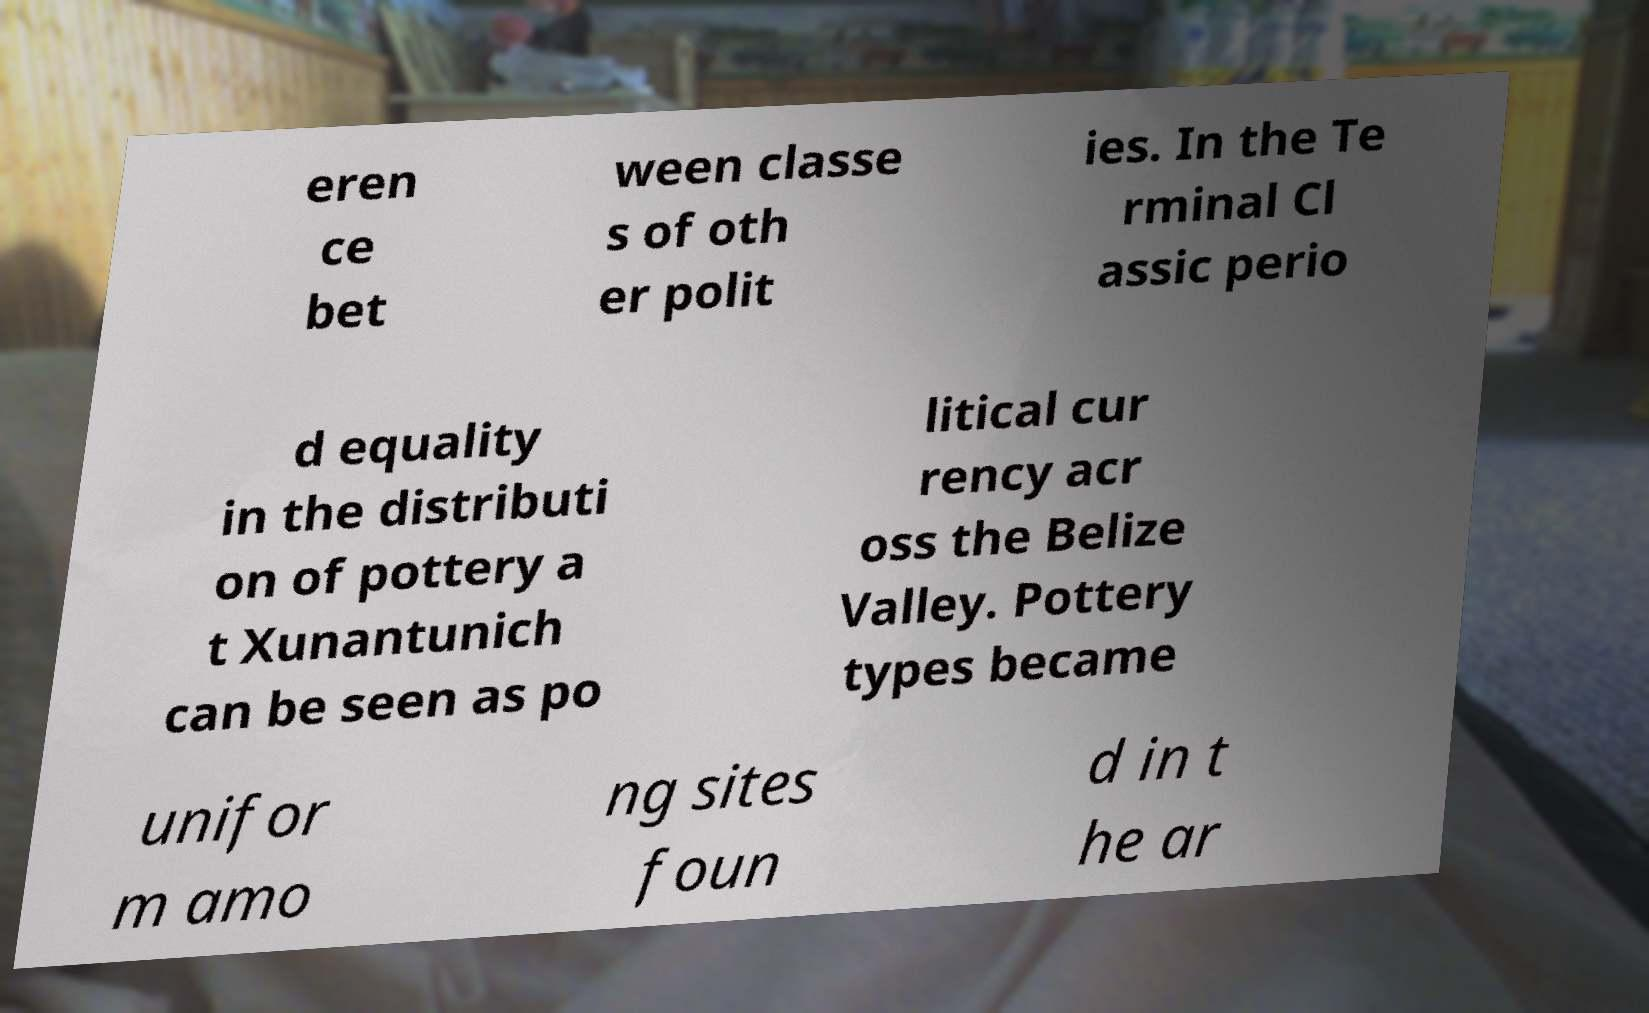For documentation purposes, I need the text within this image transcribed. Could you provide that? eren ce bet ween classe s of oth er polit ies. In the Te rminal Cl assic perio d equality in the distributi on of pottery a t Xunantunich can be seen as po litical cur rency acr oss the Belize Valley. Pottery types became unifor m amo ng sites foun d in t he ar 